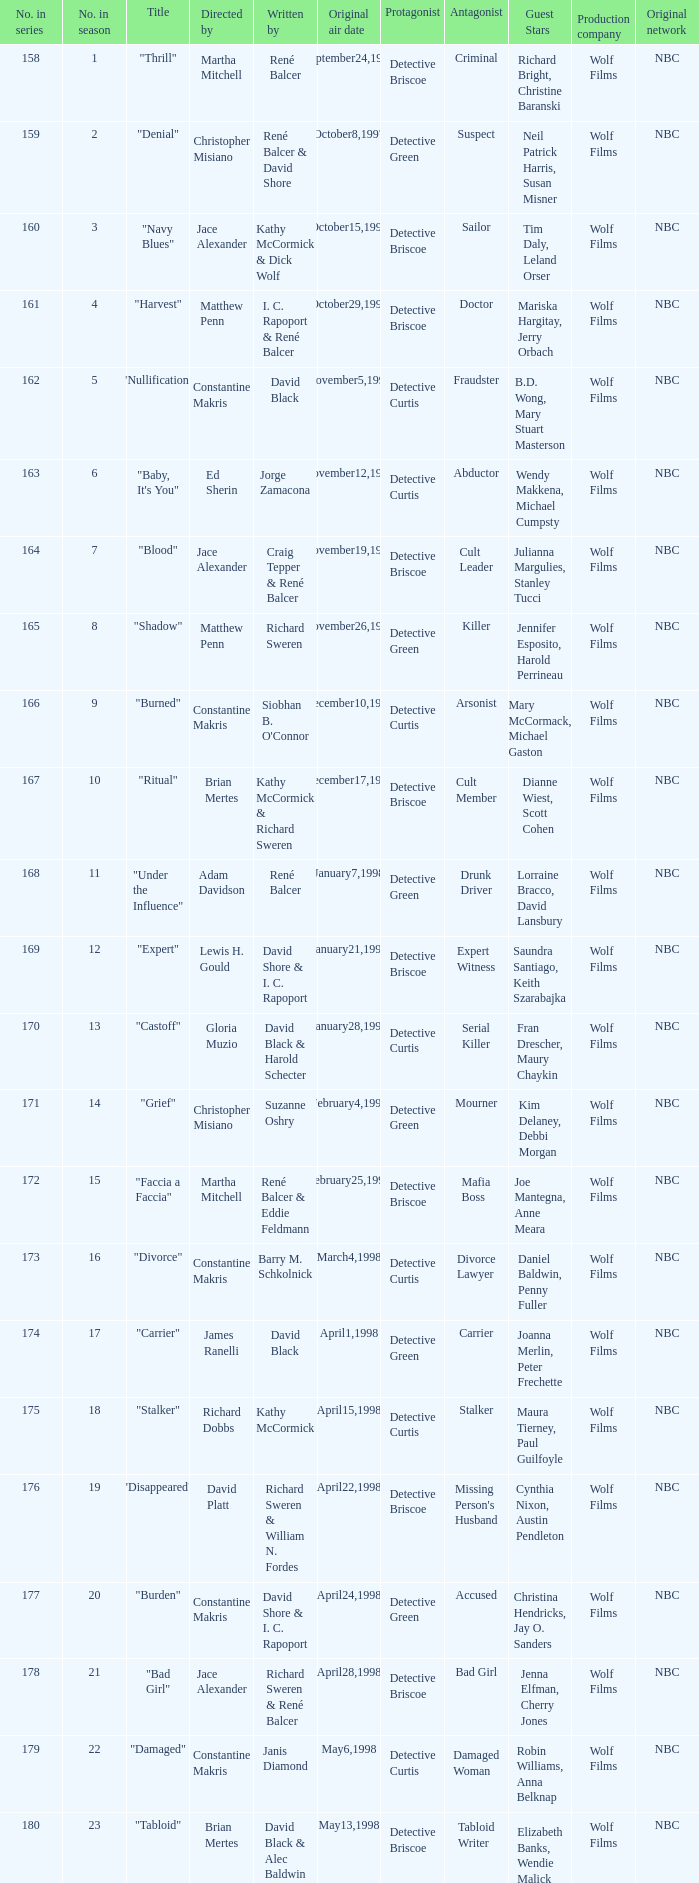The first episode in this season had what number in the series?  158.0. Help me parse the entirety of this table. {'header': ['No. in series', 'No. in season', 'Title', 'Directed by', 'Written by', 'Original air date', 'Protagonist', 'Antagonist', 'Guest Stars', 'Production company', 'Original network'], 'rows': [['158', '1', '"Thrill"', 'Martha Mitchell', 'René Balcer', 'September24,1997', 'Detective Briscoe', 'Criminal', 'Richard Bright, Christine Baranski', 'Wolf Films', 'NBC'], ['159', '2', '"Denial"', 'Christopher Misiano', 'René Balcer & David Shore', 'October8,1997', 'Detective Green', 'Suspect', 'Neil Patrick Harris, Susan Misner', 'Wolf Films', 'NBC'], ['160', '3', '"Navy Blues"', 'Jace Alexander', 'Kathy McCormick & Dick Wolf', 'October15,1997', 'Detective Briscoe', 'Sailor', 'Tim Daly, Leland Orser', 'Wolf Films', 'NBC'], ['161', '4', '"Harvest"', 'Matthew Penn', 'I. C. Rapoport & René Balcer', 'October29,1997', 'Detective Briscoe', 'Doctor', 'Mariska Hargitay, Jerry Orbach', 'Wolf Films', 'NBC'], ['162', '5', '"Nullification"', 'Constantine Makris', 'David Black', 'November5,1997', 'Detective Curtis', 'Fraudster', 'B.D. Wong, Mary Stuart Masterson', 'Wolf Films', 'NBC'], ['163', '6', '"Baby, It\'s You"', 'Ed Sherin', 'Jorge Zamacona', 'November12,1997', 'Detective Curtis', 'Abductor', 'Wendy Makkena, Michael Cumpsty', 'Wolf Films', 'NBC'], ['164', '7', '"Blood"', 'Jace Alexander', 'Craig Tepper & René Balcer', 'November19,1997', 'Detective Briscoe', 'Cult Leader', 'Julianna Margulies, Stanley Tucci', 'Wolf Films', 'NBC'], ['165', '8', '"Shadow"', 'Matthew Penn', 'Richard Sweren', 'November26,1997', 'Detective Green', 'Killer', 'Jennifer Esposito, Harold Perrineau', 'Wolf Films', 'NBC'], ['166', '9', '"Burned"', 'Constantine Makris', "Siobhan B. O'Connor", 'December10,1997', 'Detective Curtis', 'Arsonist', 'Mary McCormack, Michael Gaston', 'Wolf Films', 'NBC'], ['167', '10', '"Ritual"', 'Brian Mertes', 'Kathy McCormick & Richard Sweren', 'December17,1997', 'Detective Briscoe', 'Cult Member', 'Dianne Wiest, Scott Cohen', 'Wolf Films', 'NBC'], ['168', '11', '"Under the Influence"', 'Adam Davidson', 'René Balcer', 'January7,1998', 'Detective Green', 'Drunk Driver', 'Lorraine Bracco, David Lansbury', 'Wolf Films', 'NBC'], ['169', '12', '"Expert"', 'Lewis H. Gould', 'David Shore & I. C. Rapoport', 'January21,1998', 'Detective Briscoe', 'Expert Witness', 'Saundra Santiago, Keith Szarabajka', 'Wolf Films', 'NBC'], ['170', '13', '"Castoff"', 'Gloria Muzio', 'David Black & Harold Schecter', 'January28,1998', 'Detective Curtis', 'Serial Killer', 'Fran Drescher, Maury Chaykin', 'Wolf Films', 'NBC'], ['171', '14', '"Grief"', 'Christopher Misiano', 'Suzanne Oshry', 'February4,1998', 'Detective Green', 'Mourner', 'Kim Delaney, Debbi Morgan', 'Wolf Films', 'NBC'], ['172', '15', '"Faccia a Faccia"', 'Martha Mitchell', 'René Balcer & Eddie Feldmann', 'February25,1998', 'Detective Briscoe', 'Mafia Boss', 'Joe Mantegna, Anne Meara', 'Wolf Films', 'NBC'], ['173', '16', '"Divorce"', 'Constantine Makris', 'Barry M. Schkolnick', 'March4,1998', 'Detective Curtis', 'Divorce Lawyer', 'Daniel Baldwin, Penny Fuller', 'Wolf Films', 'NBC'], ['174', '17', '"Carrier"', 'James Ranelli', 'David Black', 'April1,1998', 'Detective Green', 'Carrier', 'Joanna Merlin, Peter Frechette', 'Wolf Films', 'NBC'], ['175', '18', '"Stalker"', 'Richard Dobbs', 'Kathy McCormick', 'April15,1998', 'Detective Curtis', 'Stalker', 'Maura Tierney, Paul Guilfoyle', 'Wolf Films', 'NBC'], ['176', '19', '"Disappeared"', 'David Platt', 'Richard Sweren & William N. Fordes', 'April22,1998', 'Detective Briscoe', "Missing Person's Husband", 'Cynthia Nixon, Austin Pendleton', 'Wolf Films', 'NBC'], ['177', '20', '"Burden"', 'Constantine Makris', 'David Shore & I. C. Rapoport', 'April24,1998', 'Detective Green', 'Accused', 'Christina Hendricks, Jay O. Sanders', 'Wolf Films', 'NBC'], ['178', '21', '"Bad Girl"', 'Jace Alexander', 'Richard Sweren & René Balcer', 'April28,1998', 'Detective Briscoe', 'Bad Girl', 'Jenna Elfman, Cherry Jones', 'Wolf Films', 'NBC'], ['179', '22', '"Damaged"', 'Constantine Makris', 'Janis Diamond', 'May6,1998', 'Detective Curtis', 'Damaged Woman', 'Robin Williams, Anna Belknap', 'Wolf Films', 'NBC'], ['180', '23', '"Tabloid"', 'Brian Mertes', 'David Black & Alec Baldwin', 'May13,1998', 'Detective Briscoe', 'Tabloid Writer', 'Elizabeth Banks, Wendie Malick', 'Wolf Films', 'NBC']]} 